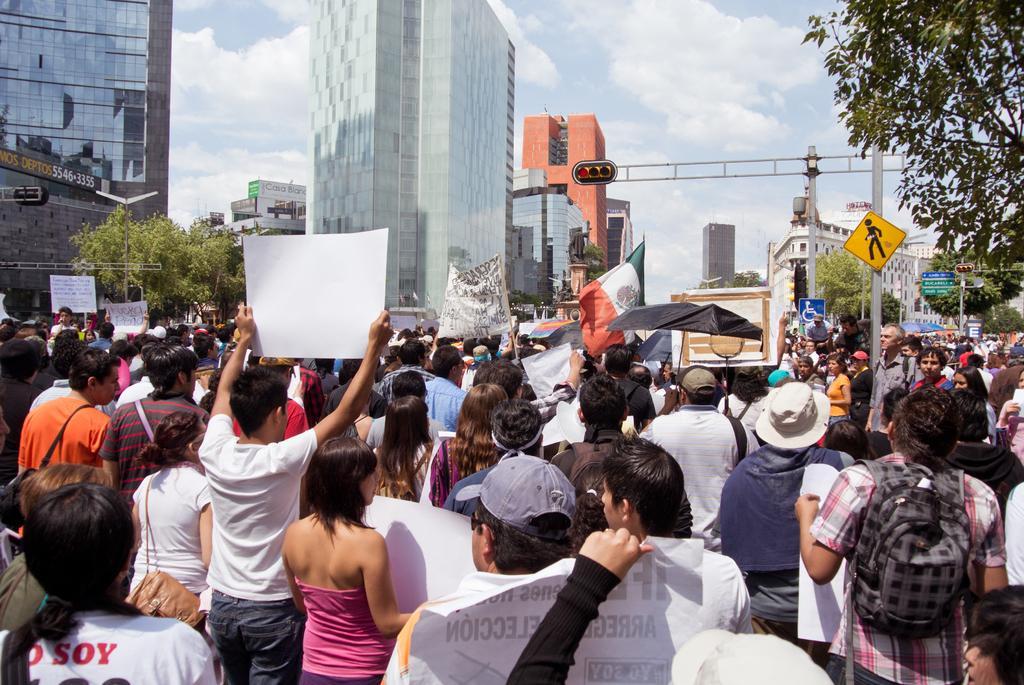Please provide a concise description of this image. In this picture I can observe some people standing on the road. There are men and women in this picture. Some of them are holding charts in their hands. In the background there are buildings, trees and some clouds in the sky. 